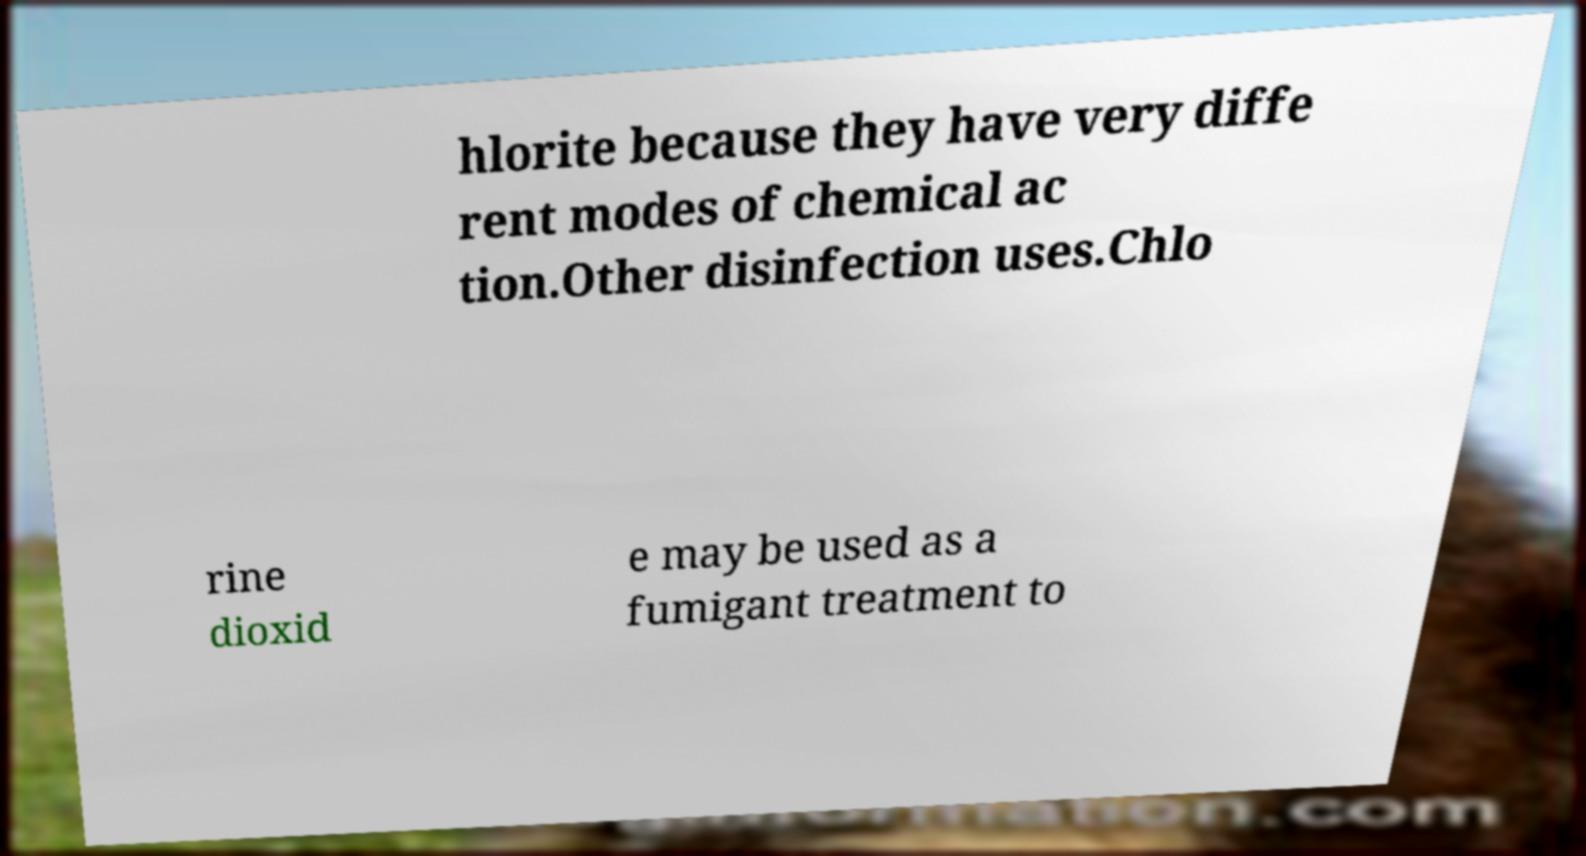Can you accurately transcribe the text from the provided image for me? hlorite because they have very diffe rent modes of chemical ac tion.Other disinfection uses.Chlo rine dioxid e may be used as a fumigant treatment to 